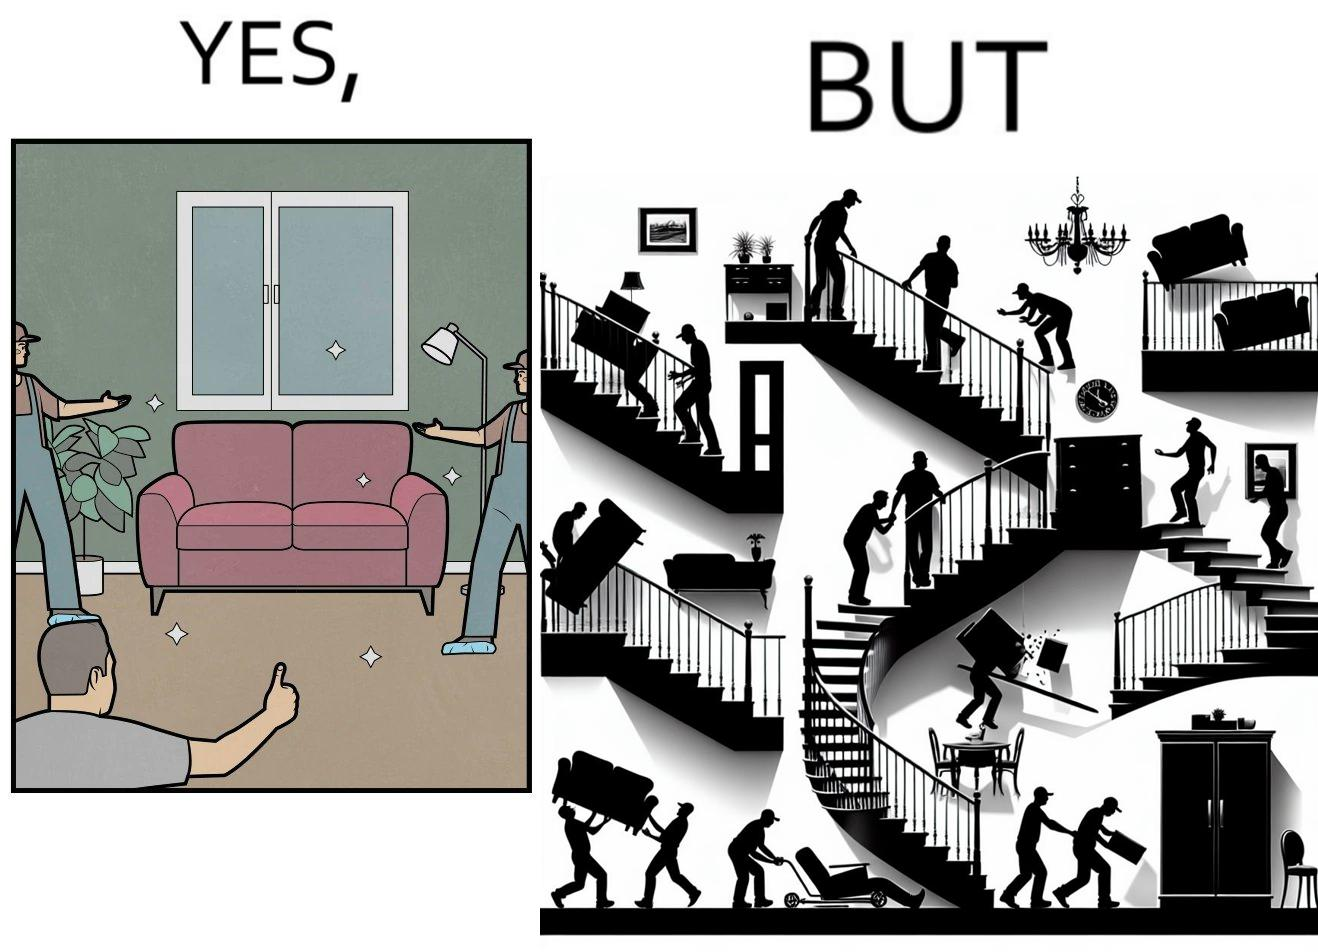Provide a description of this image. The images are funny since they show how even though the hired movers achieve their task of moving in furniture, in the process, the cause damage to the whole house 